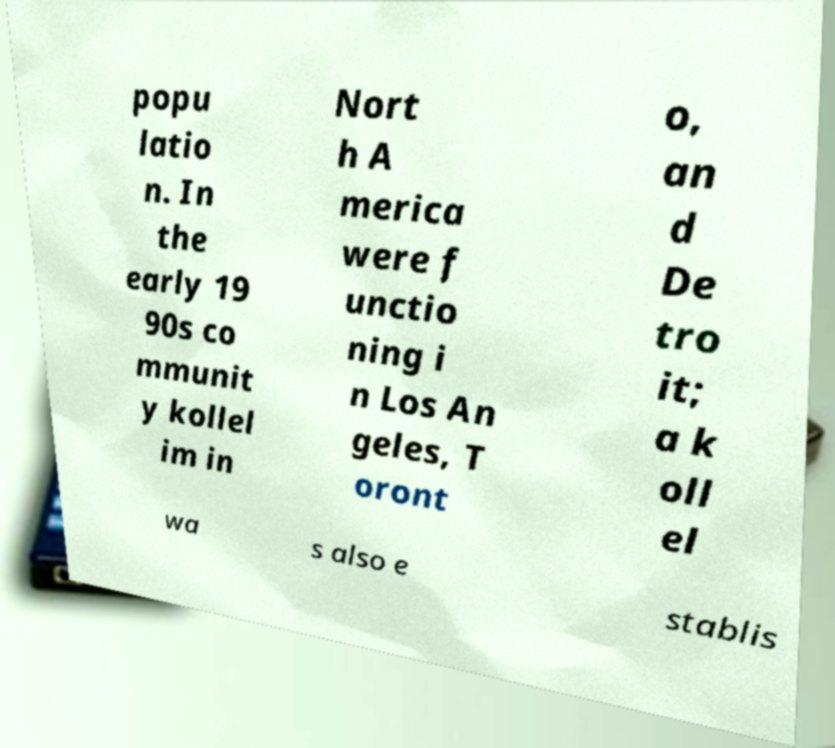Could you assist in decoding the text presented in this image and type it out clearly? popu latio n. In the early 19 90s co mmunit y kollel im in Nort h A merica were f unctio ning i n Los An geles, T oront o, an d De tro it; a k oll el wa s also e stablis 